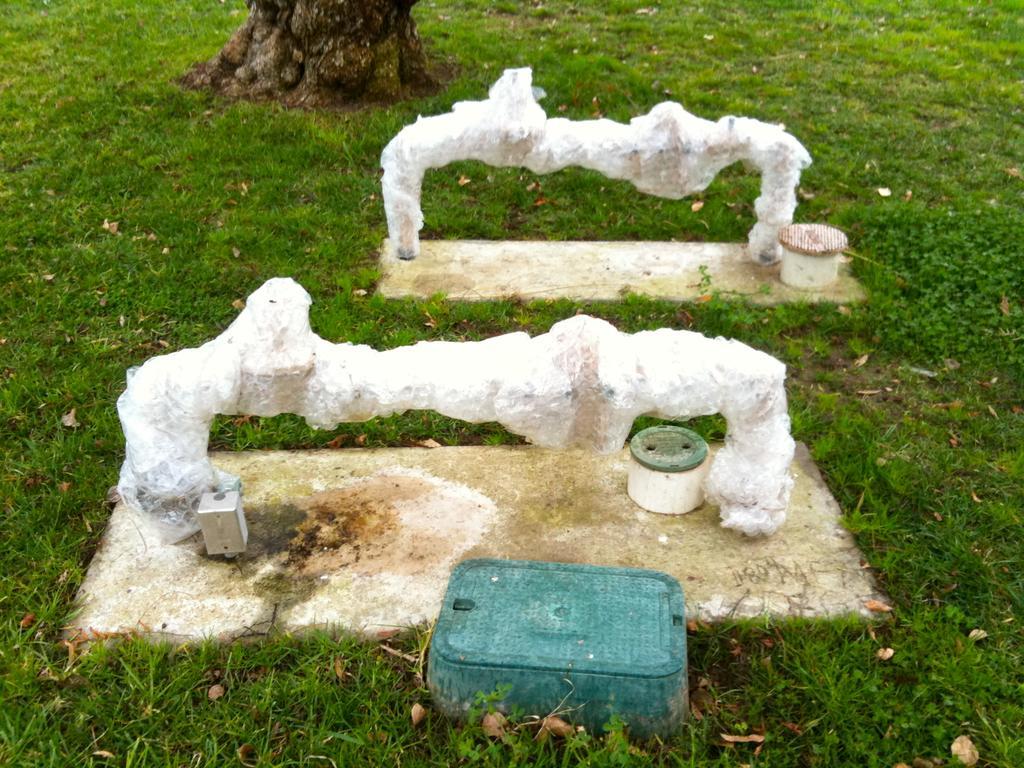Please provide a concise description of this image. In this image, we can see the ground covered with some objects. We can also see some grass and dried leaves. We can see the trunk of a tree at the top. 